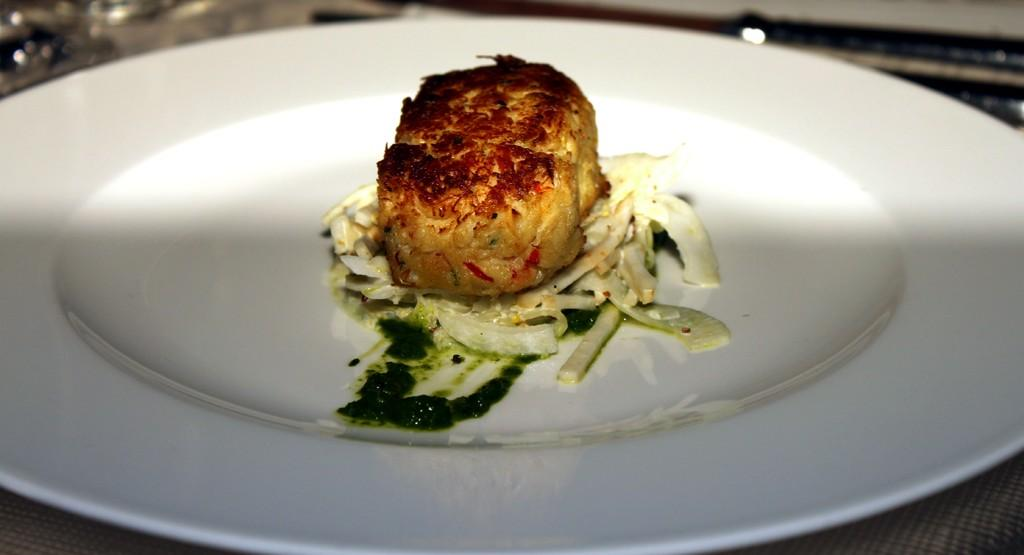What is the main subject of the image? There is a food item in the image. How is the food item presented in the image? The food item is served on a white plate. What condition is the person's hands in while holding the plate in the image? There is no person holding the plate in the image, so we cannot determine the condition of their hands. 